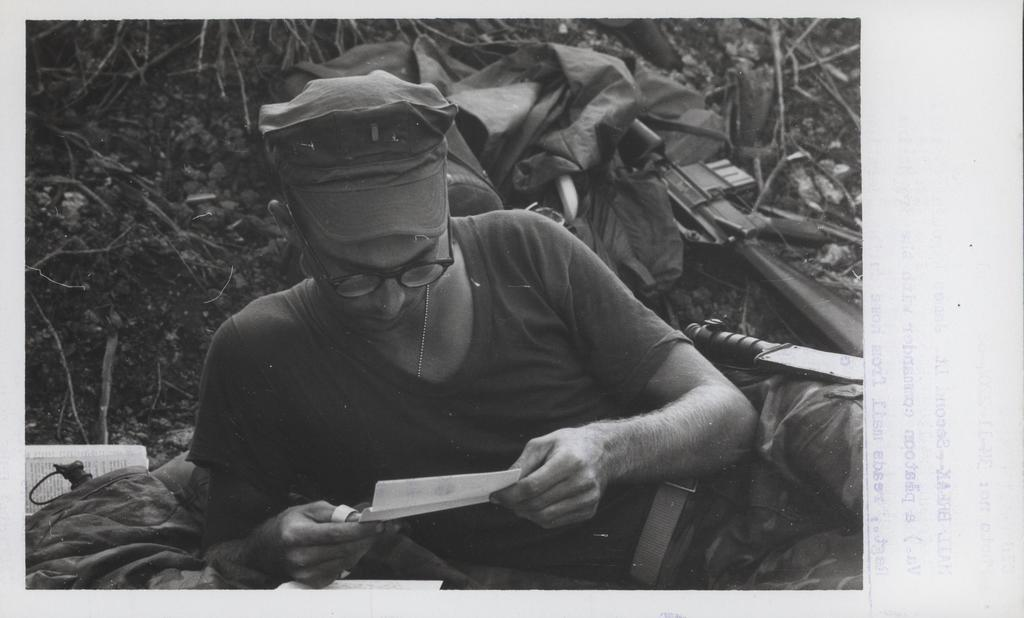What is the color scheme of the image? The image is black and white. Can you describe the person in the image? The person is wearing a cap and lying down. What is the person holding in the image? The person is holding a paper. What weapons are visible on the backside of the person? There is a gun and a knife visible on the backside of the person. How many donkeys can be seen in the image? There are no donkeys present in the image. What type of man is depicted in the image? The provided facts do not mention the gender or any specific characteristics of the person in the image, so we cannot determine the type of man depicted. 